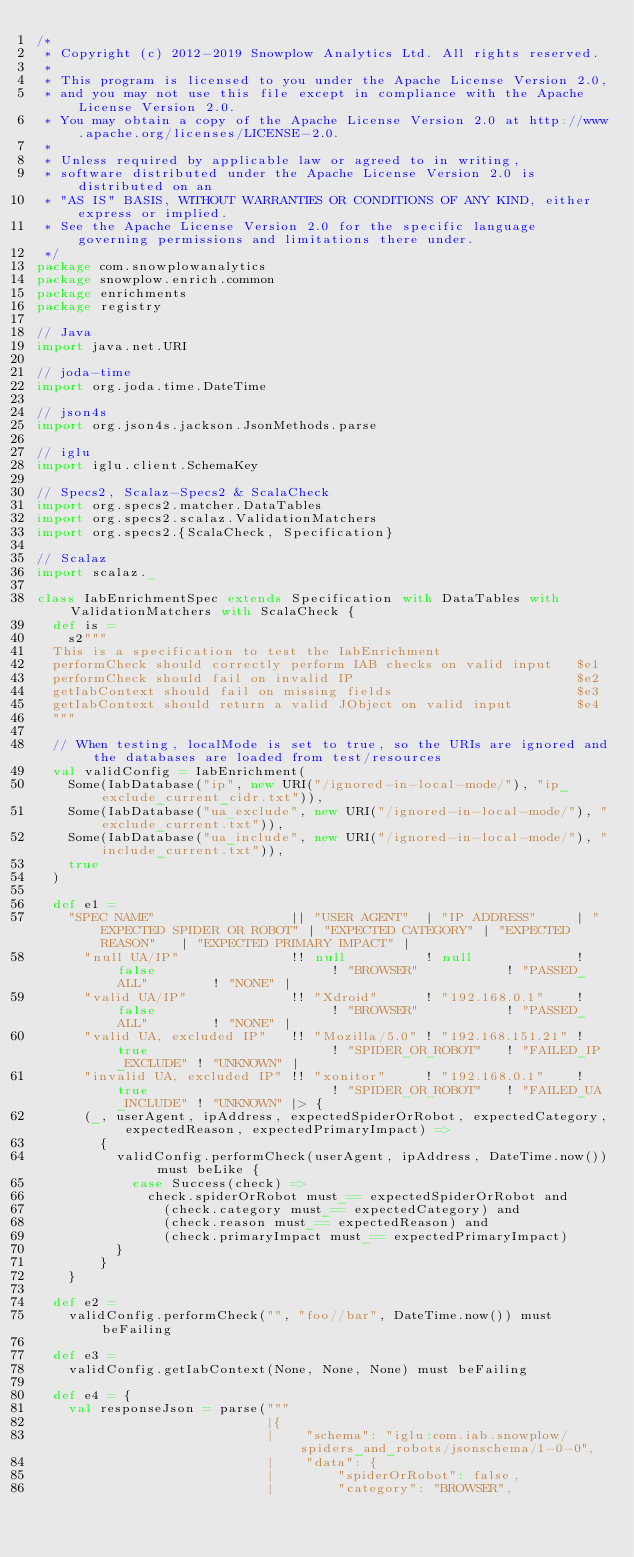<code> <loc_0><loc_0><loc_500><loc_500><_Scala_>/*
 * Copyright (c) 2012-2019 Snowplow Analytics Ltd. All rights reserved.
 *
 * This program is licensed to you under the Apache License Version 2.0,
 * and you may not use this file except in compliance with the Apache License Version 2.0.
 * You may obtain a copy of the Apache License Version 2.0 at http://www.apache.org/licenses/LICENSE-2.0.
 *
 * Unless required by applicable law or agreed to in writing,
 * software distributed under the Apache License Version 2.0 is distributed on an
 * "AS IS" BASIS, WITHOUT WARRANTIES OR CONDITIONS OF ANY KIND, either express or implied.
 * See the Apache License Version 2.0 for the specific language governing permissions and limitations there under.
 */
package com.snowplowanalytics
package snowplow.enrich.common
package enrichments
package registry

// Java
import java.net.URI

// joda-time
import org.joda.time.DateTime

// json4s
import org.json4s.jackson.JsonMethods.parse

// iglu
import iglu.client.SchemaKey

// Specs2, Scalaz-Specs2 & ScalaCheck
import org.specs2.matcher.DataTables
import org.specs2.scalaz.ValidationMatchers
import org.specs2.{ScalaCheck, Specification}

// Scalaz
import scalaz._

class IabEnrichmentSpec extends Specification with DataTables with ValidationMatchers with ScalaCheck {
  def is =
    s2"""
  This is a specification to test the IabEnrichment
  performCheck should correctly perform IAB checks on valid input   $e1
  performCheck should fail on invalid IP                            $e2
  getIabContext should fail on missing fields                       $e3
  getIabContext should return a valid JObject on valid input        $e4
  """

  // When testing, localMode is set to true, so the URIs are ignored and the databases are loaded from test/resources
  val validConfig = IabEnrichment(
    Some(IabDatabase("ip", new URI("/ignored-in-local-mode/"), "ip_exclude_current_cidr.txt")),
    Some(IabDatabase("ua_exclude", new URI("/ignored-in-local-mode/"), "exclude_current.txt")),
    Some(IabDatabase("ua_include", new URI("/ignored-in-local-mode/"), "include_current.txt")),
    true
  )

  def e1 =
    "SPEC NAME"                 || "USER AGENT"  | "IP ADDRESS"     | "EXPECTED SPIDER OR ROBOT" | "EXPECTED CATEGORY" | "EXPECTED REASON"   | "EXPECTED PRIMARY IMPACT" |
      "null UA/IP"              !! null          ! null             ! false                      ! "BROWSER"           ! "PASSED_ALL"        ! "NONE" |
      "valid UA/IP"             !! "Xdroid"      ! "192.168.0.1"    ! false                      ! "BROWSER"           ! "PASSED_ALL"        ! "NONE" |
      "valid UA, excluded IP"   !! "Mozilla/5.0" ! "192.168.151.21" ! true                       ! "SPIDER_OR_ROBOT"   ! "FAILED_IP_EXCLUDE" ! "UNKNOWN" |
      "invalid UA, excluded IP" !! "xonitor"     ! "192.168.0.1"    ! true                       ! "SPIDER_OR_ROBOT"   ! "FAILED_UA_INCLUDE" ! "UNKNOWN" |> {
      (_, userAgent, ipAddress, expectedSpiderOrRobot, expectedCategory, expectedReason, expectedPrimaryImpact) =>
        {
          validConfig.performCheck(userAgent, ipAddress, DateTime.now()) must beLike {
            case Success(check) =>
              check.spiderOrRobot must_== expectedSpiderOrRobot and
                (check.category must_== expectedCategory) and
                (check.reason must_== expectedReason) and
                (check.primaryImpact must_== expectedPrimaryImpact)
          }
        }
    }

  def e2 =
    validConfig.performCheck("", "foo//bar", DateTime.now()) must beFailing

  def e3 =
    validConfig.getIabContext(None, None, None) must beFailing

  def e4 = {
    val responseJson = parse("""
                             |{
                             |    "schema": "iglu:com.iab.snowplow/spiders_and_robots/jsonschema/1-0-0",
                             |    "data": {
                             |        "spiderOrRobot": false,
                             |        "category": "BROWSER",</code> 